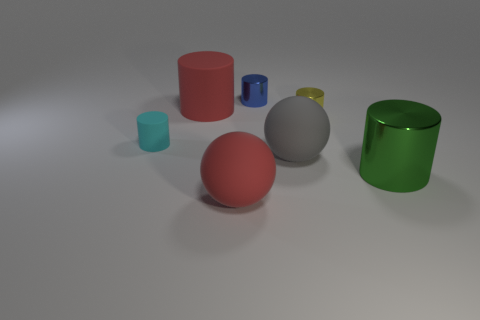Subtract all brown cylinders. Subtract all blue balls. How many cylinders are left? 5 Add 3 tiny cyan cubes. How many objects exist? 10 Subtract all balls. How many objects are left? 5 Subtract 1 cyan cylinders. How many objects are left? 6 Subtract all big red matte cylinders. Subtract all big green things. How many objects are left? 5 Add 4 rubber things. How many rubber things are left? 8 Add 7 rubber cylinders. How many rubber cylinders exist? 9 